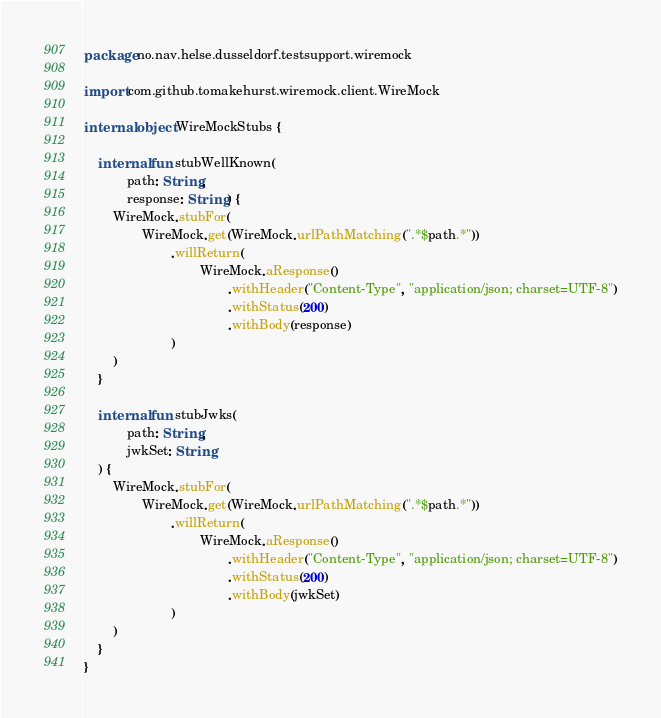<code> <loc_0><loc_0><loc_500><loc_500><_Kotlin_>package no.nav.helse.dusseldorf.testsupport.wiremock

import com.github.tomakehurst.wiremock.client.WireMock

internal object WireMockStubs {

    internal fun stubWellKnown(
            path: String,
            response: String) {
        WireMock.stubFor(
                WireMock.get(WireMock.urlPathMatching(".*$path.*"))
                        .willReturn(
                                WireMock.aResponse()
                                        .withHeader("Content-Type", "application/json; charset=UTF-8")
                                        .withStatus(200)
                                        .withBody(response)
                        )
        )
    }

    internal fun stubJwks(
            path: String,
            jwkSet: String
    ) {
        WireMock.stubFor(
                WireMock.get(WireMock.urlPathMatching(".*$path.*"))
                        .willReturn(
                                WireMock.aResponse()
                                        .withHeader("Content-Type", "application/json; charset=UTF-8")
                                        .withStatus(200)
                                        .withBody(jwkSet)
                        )
        )
    }
}</code> 